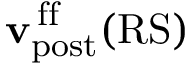Convert formula to latex. <formula><loc_0><loc_0><loc_500><loc_500>{ v } _ { p o s t } ^ { \, f f } ( R S )</formula> 